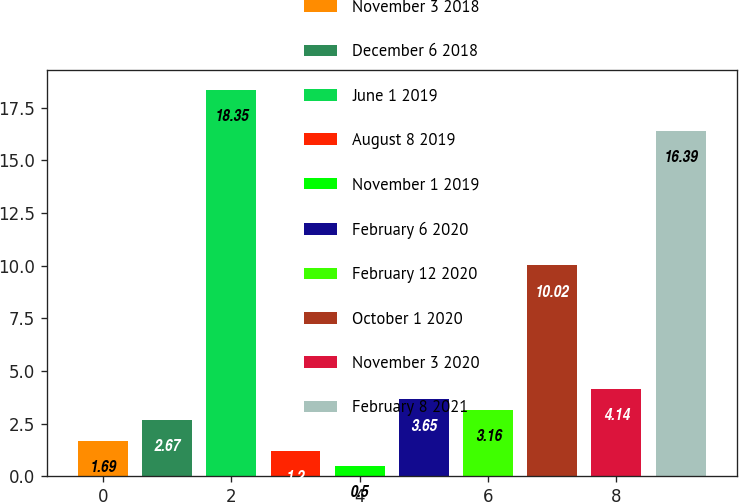<chart> <loc_0><loc_0><loc_500><loc_500><bar_chart><fcel>November 3 2018<fcel>December 6 2018<fcel>June 1 2019<fcel>August 8 2019<fcel>November 1 2019<fcel>February 6 2020<fcel>February 12 2020<fcel>October 1 2020<fcel>November 3 2020<fcel>February 8 2021<nl><fcel>1.69<fcel>2.67<fcel>18.35<fcel>1.2<fcel>0.5<fcel>3.65<fcel>3.16<fcel>10.02<fcel>4.14<fcel>16.39<nl></chart> 